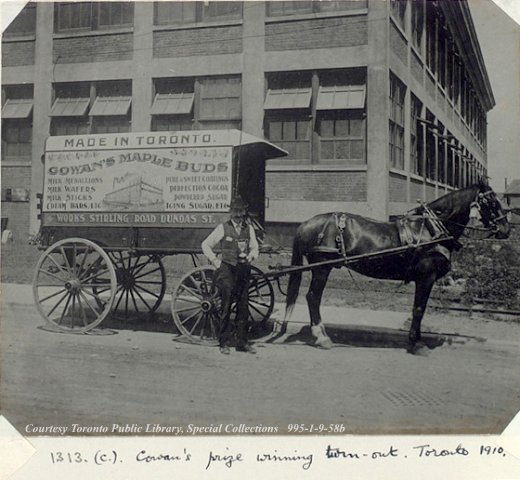<image>What number is in the bottom left corner? I am not sure about the number in the bottom left corner. It can be '1313' or '1813'. What number is in the bottom left corner? I am not sure what number is in the bottom left corner. But it seems to be '1313'. 